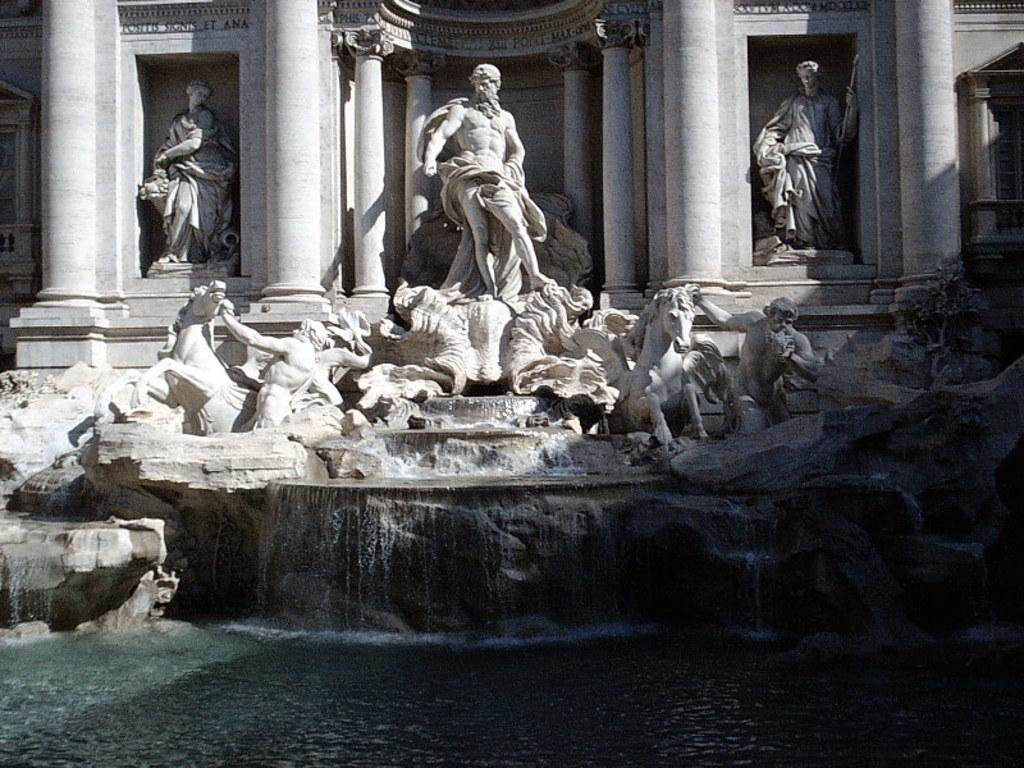What is located in the middle of the image? There are statues in the middle of the image. What is present at the bottom of the image? There is water at the bottom of the image. What type of artwork can be seen in the image? There are sculptures in the image. How does the carpenter use the fire to create the sculptures in the image? There is no carpenter or fire present in the image; it features statues and sculptures near water. 